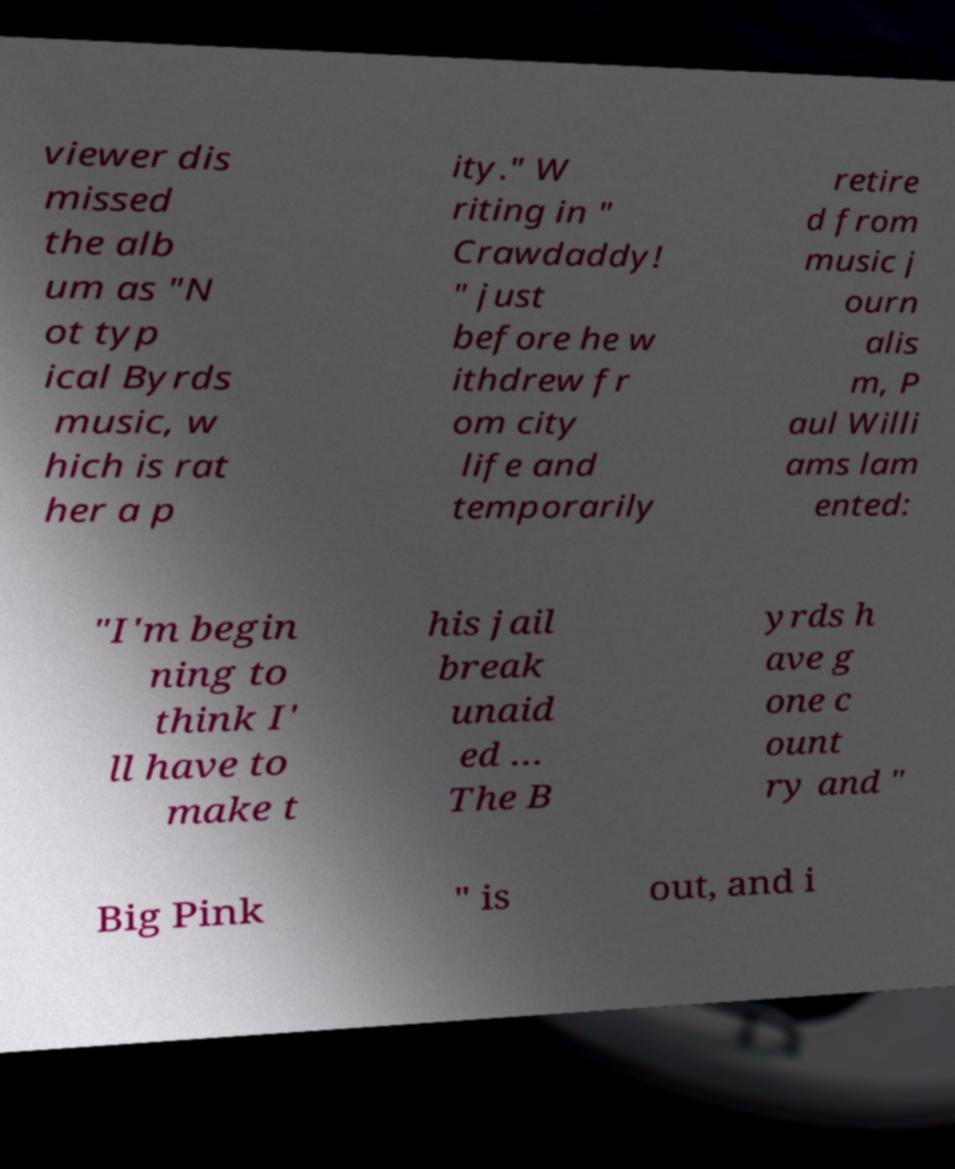For documentation purposes, I need the text within this image transcribed. Could you provide that? viewer dis missed the alb um as "N ot typ ical Byrds music, w hich is rat her a p ity." W riting in " Crawdaddy! " just before he w ithdrew fr om city life and temporarily retire d from music j ourn alis m, P aul Willi ams lam ented: "I'm begin ning to think I' ll have to make t his jail break unaid ed … The B yrds h ave g one c ount ry and " Big Pink " is out, and i 